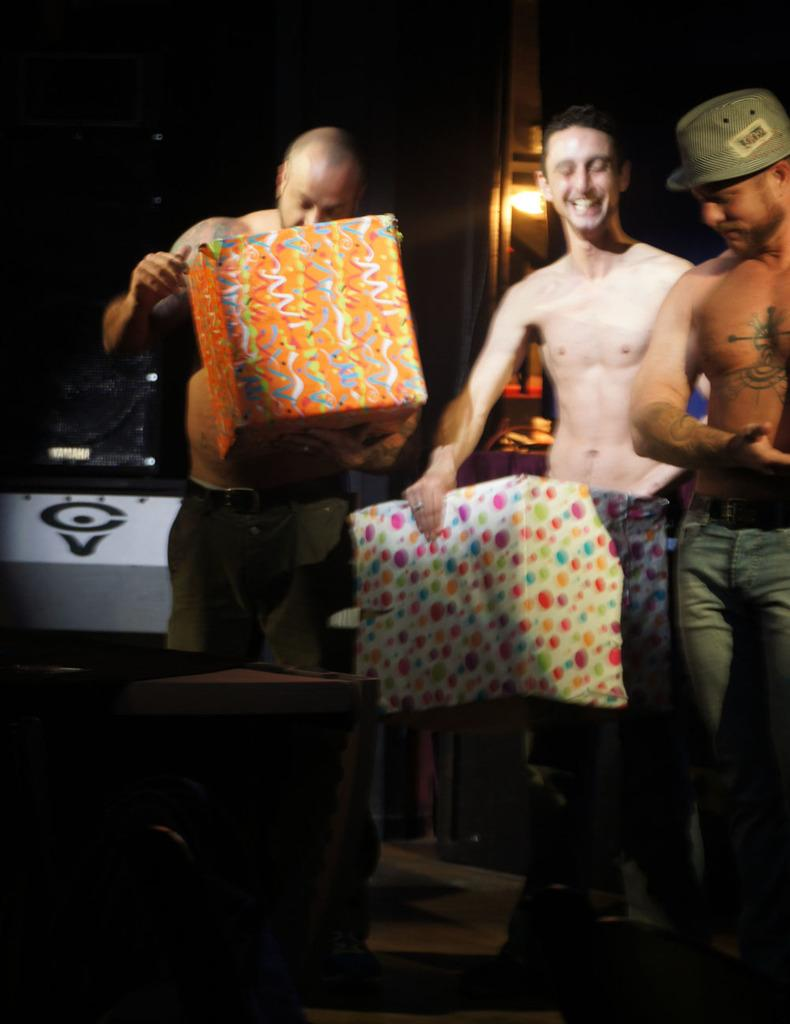How many people are in the image? There are three persons standing in the middle of the image. What are two of the persons doing? Two of the persons are holding an object. Can you describe any other objects visible in the image? There are other objects visible in the background, but their specific details are not mentioned in the provided facts. Are there any yaks in the image? No, there are no yaks present in the image. 